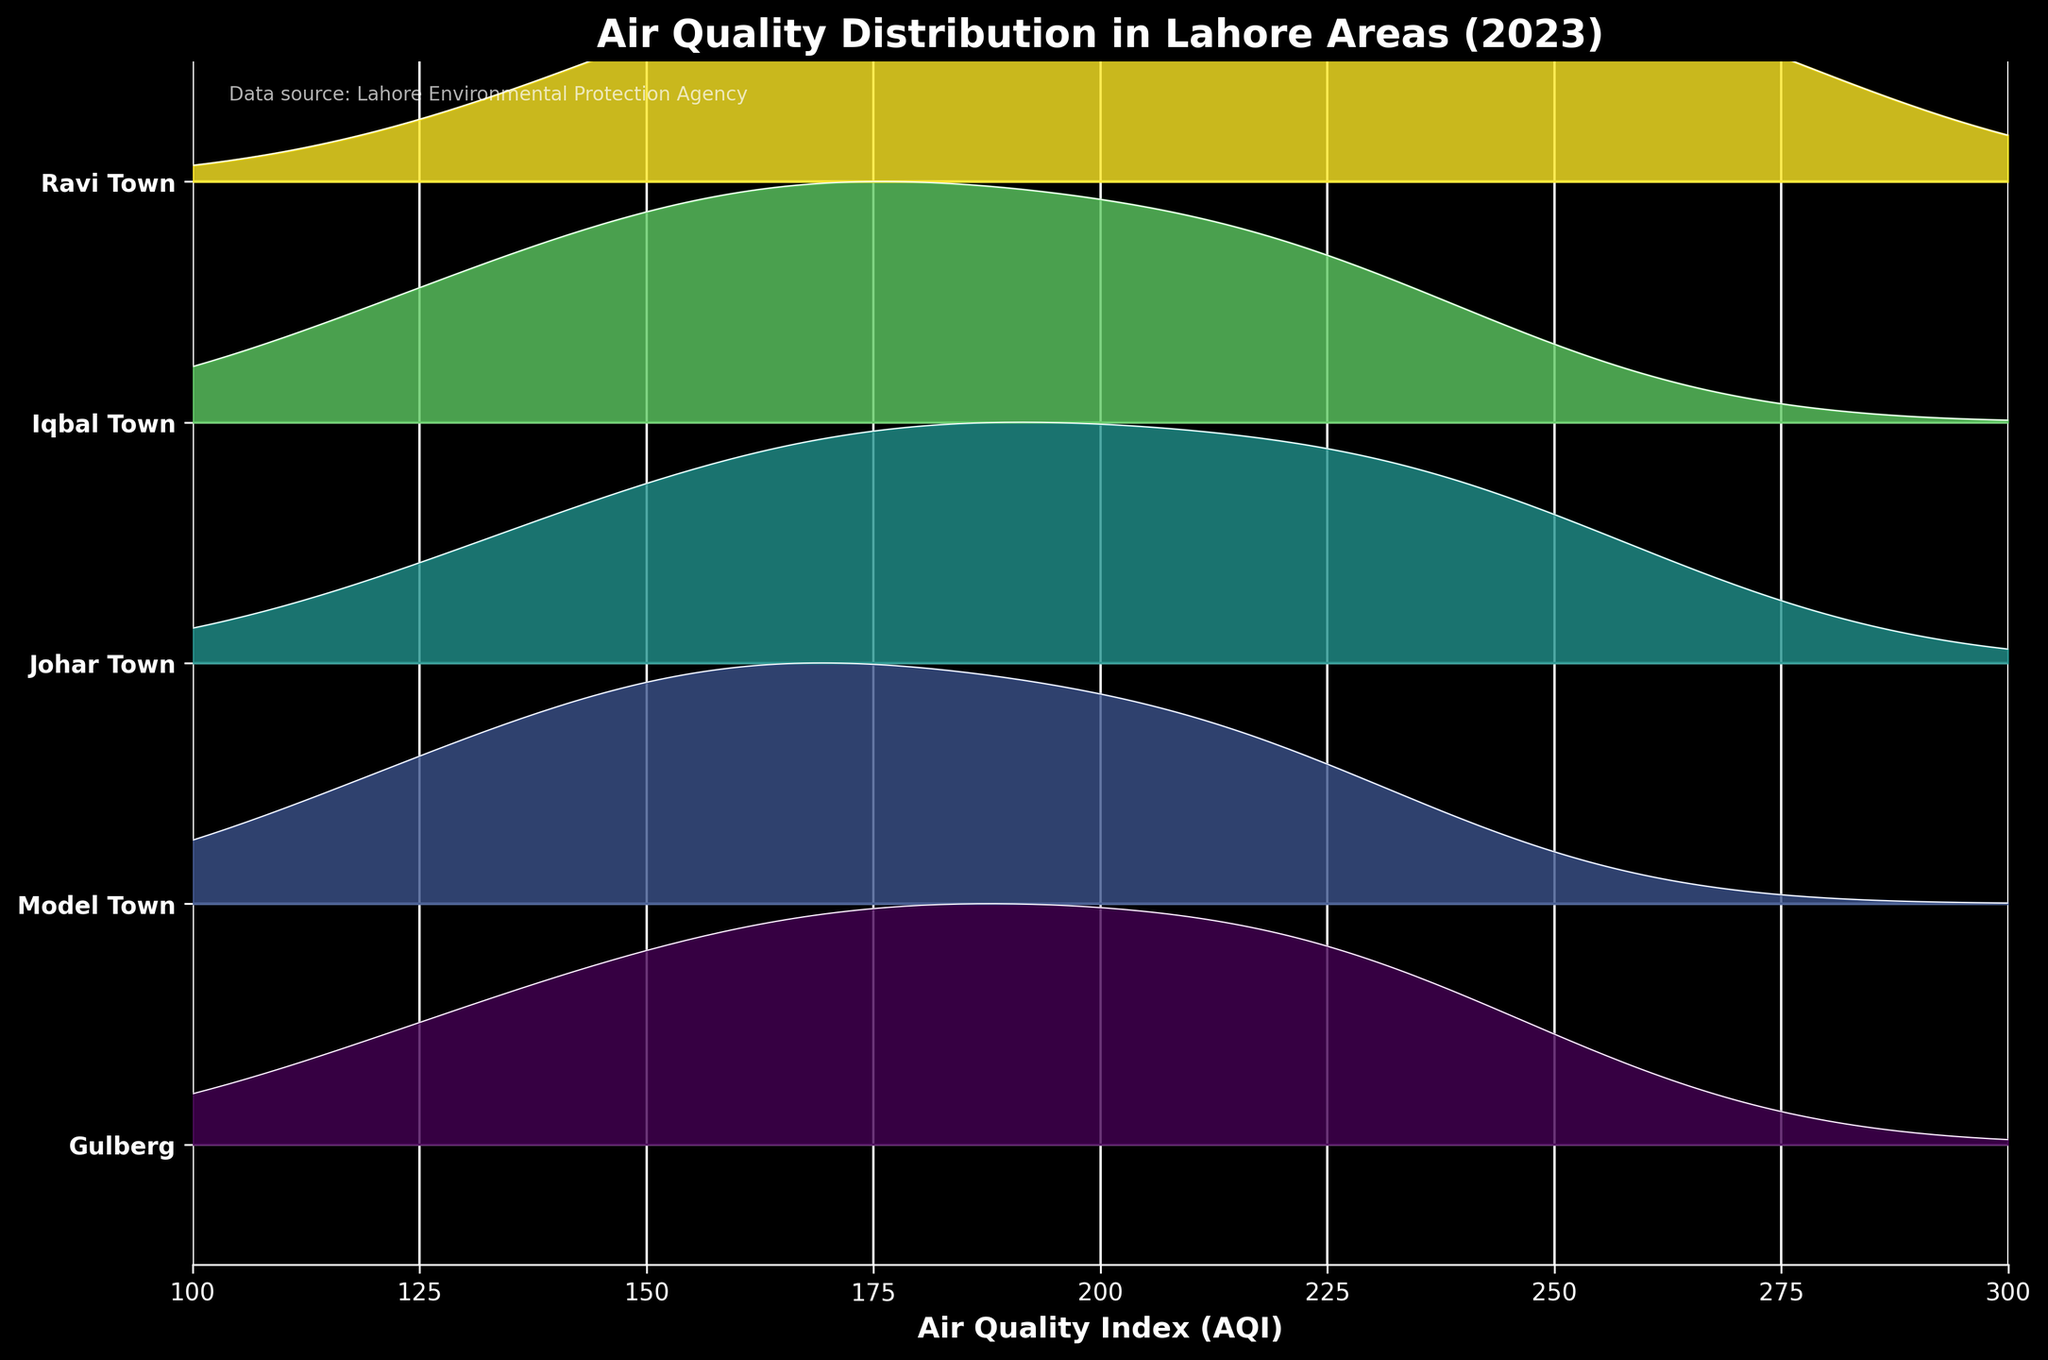What's the title of the plot? The title is the text found at the top of the plot, designed to give viewers a quick understanding of what the plot represents. Here, it is "Air Quality Distribution in Lahore Areas (2023)".
Answer: Air Quality Distribution in Lahore Areas (2023) What does the x-axis represent? The x-axis shows the measurement scale for the Air Quality Index (AQI), which indicates the level of air pollution.
Answer: Air Quality Index (AQI) Which area has the highest maximum AQI value throughout the year according to the plot? Looking at the peaks of the ridges, Ravi Town seems to have the highest maximum AQI value, suggested by its higher-density peak compared to other areas.
Answer: Ravi Town What pattern do you observe about air quality distribution across the different areas of Lahore? Each ridge shows the distribution of AQI values over time for different areas. The Gulberg and Model Town areas have somewhat lower, narrower distributions compared to the higher and wider distributions seen in Ravi Town, indicating poorer air quality in Ravi Town.
Answer: Ravi Town has poorer air quality distributions compared to Gulberg and Model Town How does the air quality of Johar Town compare to that of Iqbal Town? By comparing the ridges of Johar Town and Iqbal Town, both seem to have similar patterns in terms of distribution width, but Johar Town's ridge appears slightly higher, indicating worse air quality.
Answer: Johar Town has worse air quality Which months generally show lower AQI values across all areas? The distributions show lower rightward shifts, indicating better air quality, around the mid-year (April and July). This is visually evident through the narrower and lower density ridges in these months.
Answer: April and July What is the overall trend of AQI values from January to December? The ridgelines show a general trend of worsening air quality as the year progresses, with January and December having higher densities and wider distributions indicating higher AQI values.
Answer: AQI values worsen from January to December Which area shows the greatest variance in AQI levels? By visually assessing the width and height of the ridges, Ravi Town shows the greatest variance as its ridges are the widest and have the highest peaks stretching out further across the AQI values.
Answer: Ravi Town What is the range of AQI typically observed in Gulberg? The Gulberg ridge stretches from roughly 100 to 250 AQI, indicating this as the most typical range.
Answer: 100 to 250 AQI How does the midnight blue color highlight air quality differences? The varying intensities of the midnight blue color in each ridge highlight differences in air quality intensities across the different areas, with brighter areas indicating higher density and thus higher frequent AQI levels.
Answer: Higher density areas have higher AQI levels 